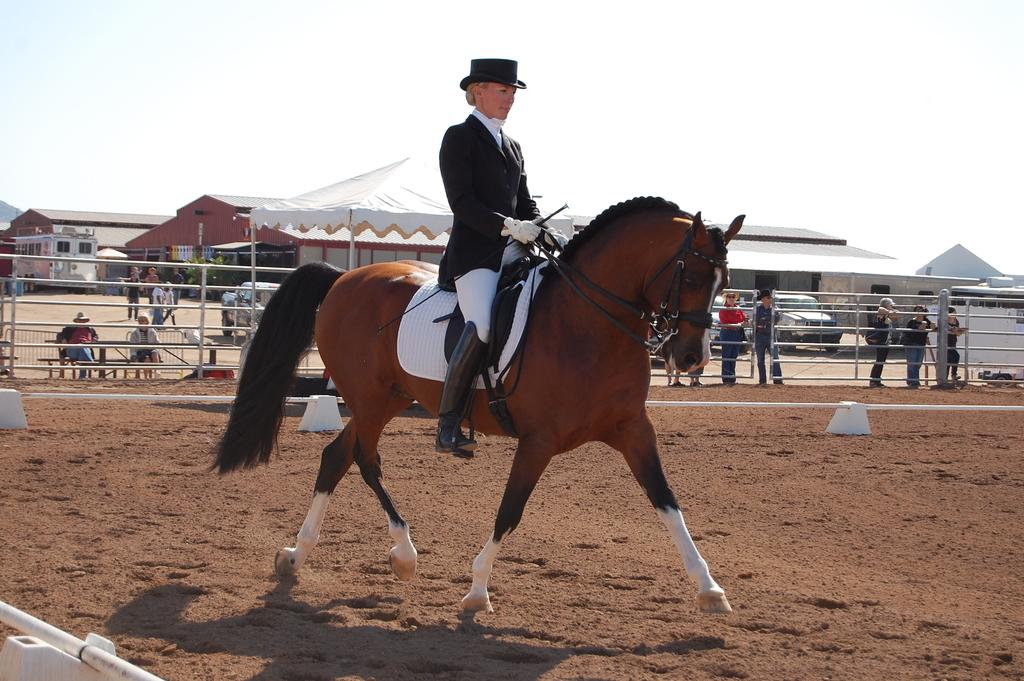What animal is present in the image? There is a horse in the image. What is the horse doing in the image? The horse is walking on the ground. Is there anyone riding the horse? Yes, there is a woman sitting on the horse. What can be seen in the background of the image? There is a group of people, a fence, a house, and the sky visible in the background of the image. What type of club is the horse using to hit the ball in the image? There is no club or ball present in the image; it features a horse walking with a woman riding it. How is the spoon being used in the image? There is no spoon present in the image. 